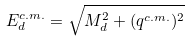<formula> <loc_0><loc_0><loc_500><loc_500>E _ { d } ^ { c . m . } = \sqrt { M _ { d } ^ { 2 } + ( q ^ { c . m . } ) ^ { 2 } }</formula> 